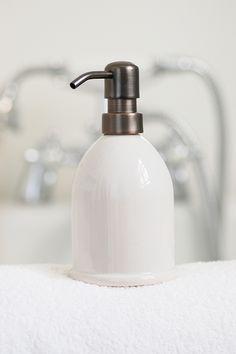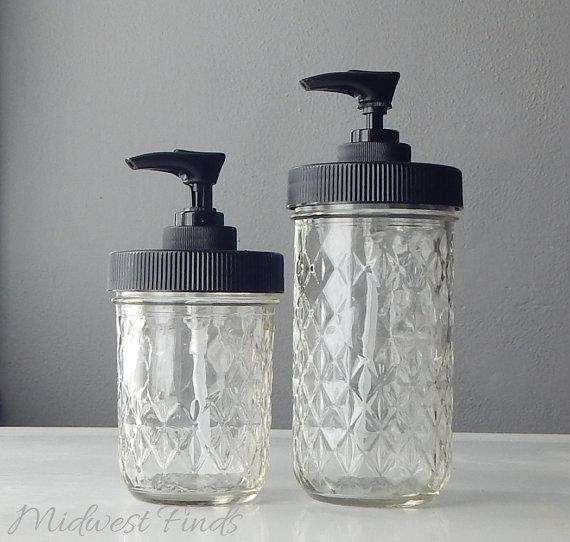The first image is the image on the left, the second image is the image on the right. Assess this claim about the two images: "One image shows a single pump-top dispenser, which is opaque white and has a left-facing nozzle.". Correct or not? Answer yes or no. Yes. The first image is the image on the left, the second image is the image on the right. Considering the images on both sides, is "There are more containers in the image on the left." valid? Answer yes or no. No. 